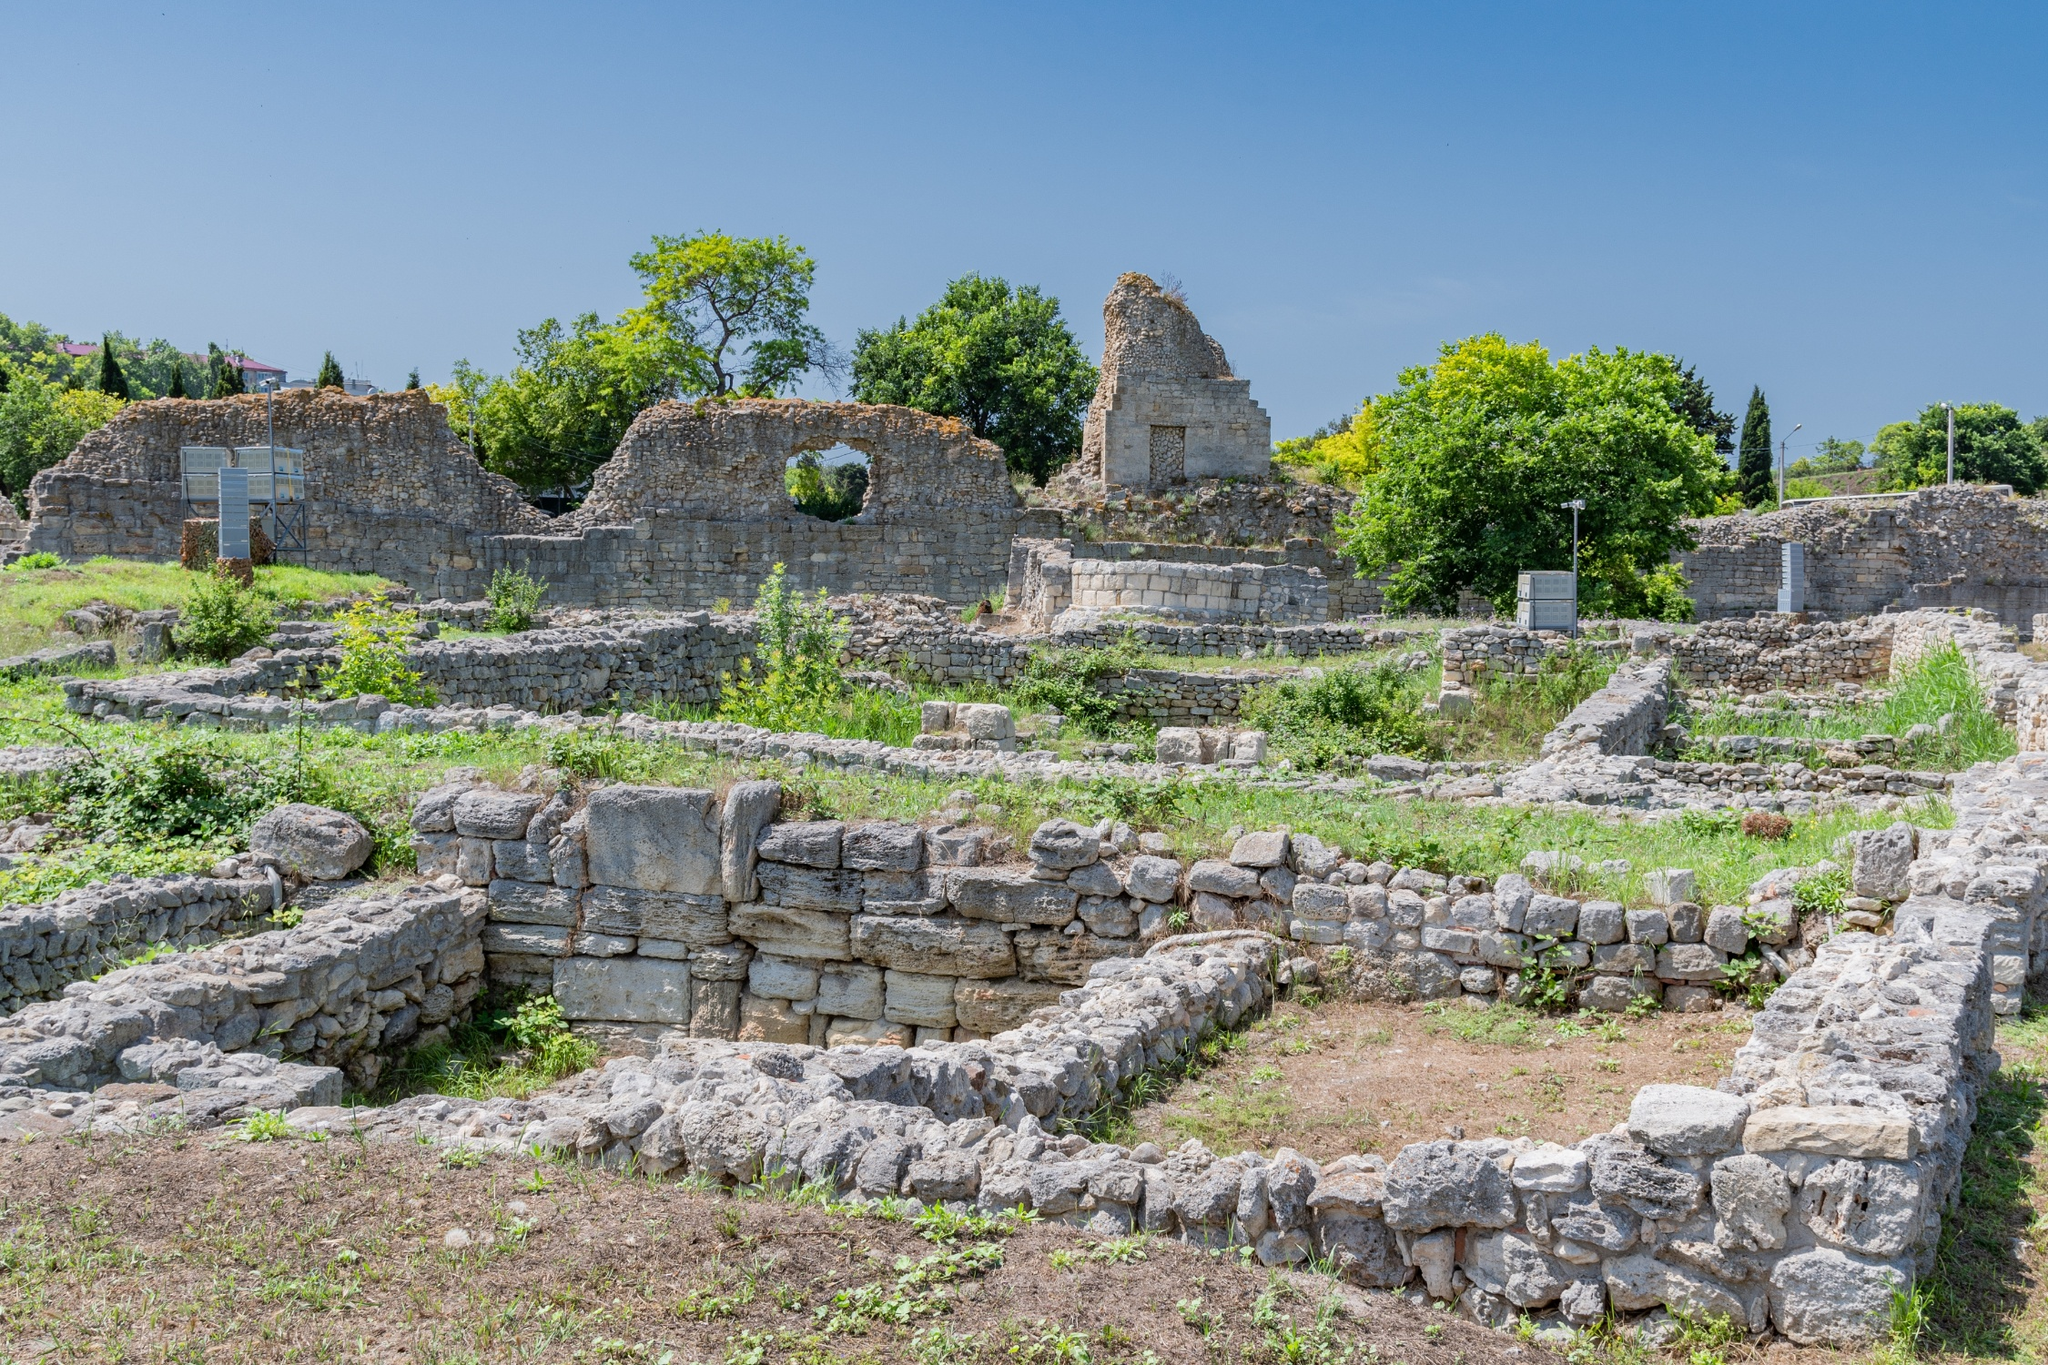If these ruins could talk, what stories might they tell us? If these ruins could talk, they might share stories of grandeur and decline, of bustling markets and quiet, sacred spaces. They could recount the footsteps that once echoed through corridors, the laughter of children playing in courtyards, and the solemnity of ceremonies held in majestic halls. These stones might whisper about the hands that built them, the artisans' skills, and the dreams and ambitions of the city's inhabitants. They could tell us about the conflicts that raged, the alliances forged, and the eventual downfall that led to their current state. The ruins are silent witnesses to the passage of time, holding within them a repository of human endeavor, culture, and history, now left for us to ponder and reconstruct. 